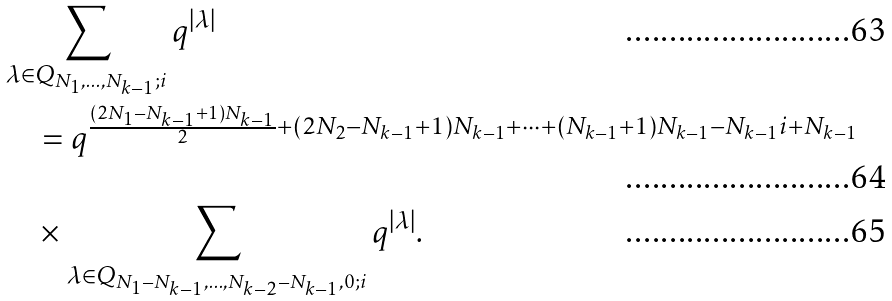Convert formula to latex. <formula><loc_0><loc_0><loc_500><loc_500>& \sum _ { \lambda \in Q _ { N _ { 1 } , \dots , N _ { k - 1 } ; i } } q ^ { | \lambda | } \\ & \quad = q ^ { \frac { ( 2 N _ { 1 } - N _ { k - 1 } + 1 ) N _ { k - 1 } } { 2 } + ( 2 N _ { 2 } - N _ { k - 1 } + 1 ) N _ { k - 1 } + \cdots + ( N _ { k - 1 } + 1 ) N _ { k - 1 } - N _ { k - 1 } i + N _ { k - 1 } } \\ & \quad \times \sum _ { \lambda \in Q _ { N _ { 1 } - N _ { k - 1 } , \dots , N _ { k - 2 } - N _ { k - 1 } , 0 ; i } } q ^ { | \lambda | } .</formula> 